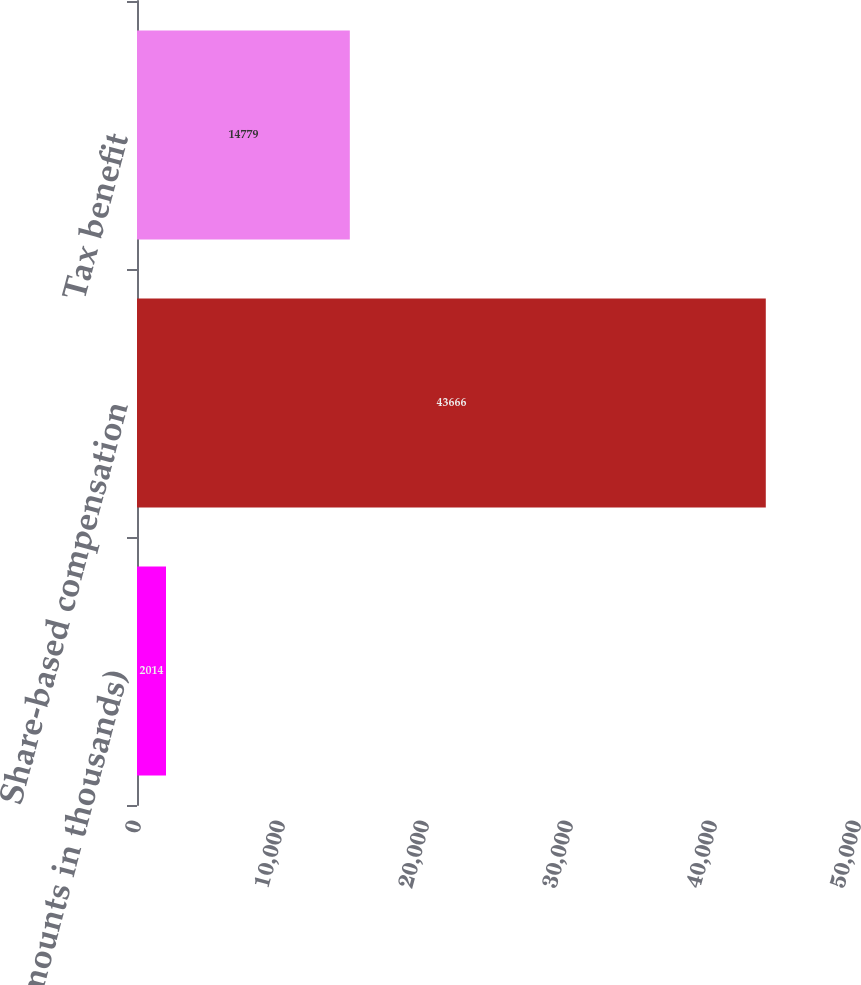Convert chart. <chart><loc_0><loc_0><loc_500><loc_500><bar_chart><fcel>(dollar amounts in thousands)<fcel>Share-based compensation<fcel>Tax benefit<nl><fcel>2014<fcel>43666<fcel>14779<nl></chart> 